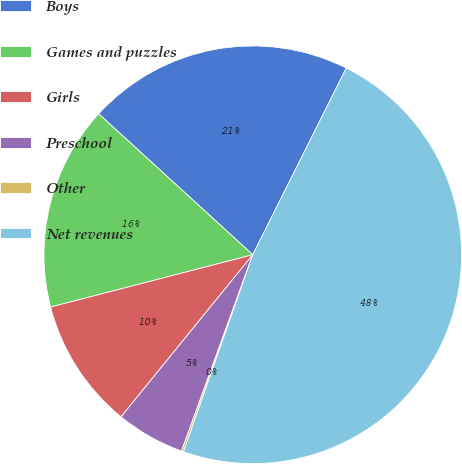Convert chart. <chart><loc_0><loc_0><loc_500><loc_500><pie_chart><fcel>Boys<fcel>Games and puzzles<fcel>Girls<fcel>Preschool<fcel>Other<fcel>Net revenues<nl><fcel>20.6%<fcel>15.82%<fcel>10.11%<fcel>5.32%<fcel>0.16%<fcel>47.99%<nl></chart> 